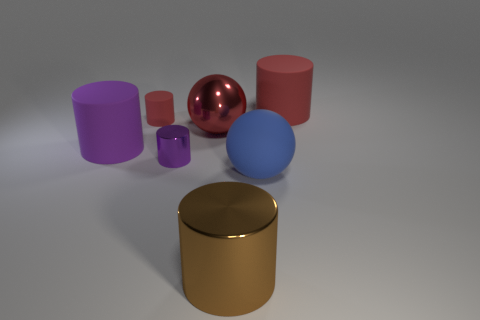Are there any metal objects of the same size as the red sphere?
Ensure brevity in your answer.  Yes. There is another shiny object that is the same shape as the small purple metallic object; what is its color?
Your answer should be very brief. Brown. Do the red cylinder in front of the large red cylinder and the metallic object that is behind the purple rubber object have the same size?
Offer a very short reply. No. Is there a tiny purple shiny thing of the same shape as the purple matte thing?
Keep it short and to the point. Yes. Are there the same number of blue matte balls on the left side of the blue matte sphere and blue matte objects?
Give a very brief answer. No. Does the blue sphere have the same size as the red ball that is left of the blue thing?
Make the answer very short. Yes. How many purple cylinders have the same material as the red ball?
Ensure brevity in your answer.  1. Is the size of the blue rubber object the same as the brown metal cylinder?
Provide a short and direct response. Yes. Is there any other thing that has the same color as the large metallic cylinder?
Keep it short and to the point. No. There is a matte object that is both in front of the shiny sphere and behind the blue matte thing; what is its shape?
Ensure brevity in your answer.  Cylinder. 